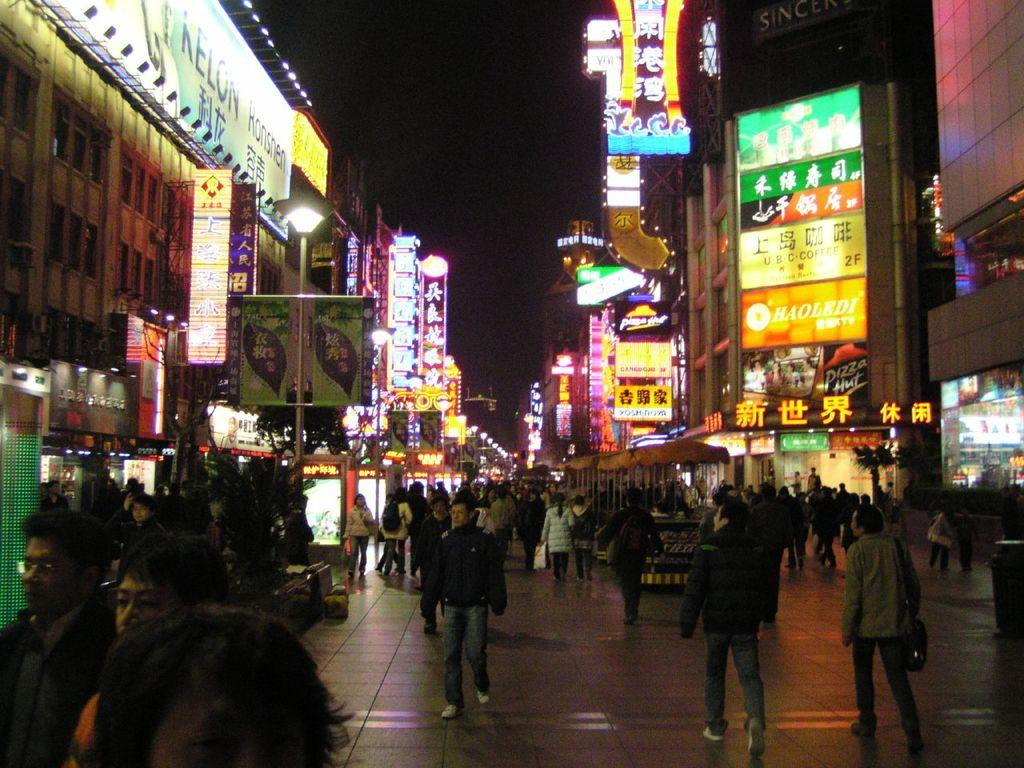What are the people in the image doing? The people in the image are walking. What type of structures can be seen in the image? There are buildings in the image. What kind of establishments are present in the image? There are shops in the image. What decorations or signs are visible in the image? There are banners in the image. What can be seen illuminating the scene in the image? There are lights visible in the image. What color is the sister's scarf in the image? There is no sister or scarf present in the image. 